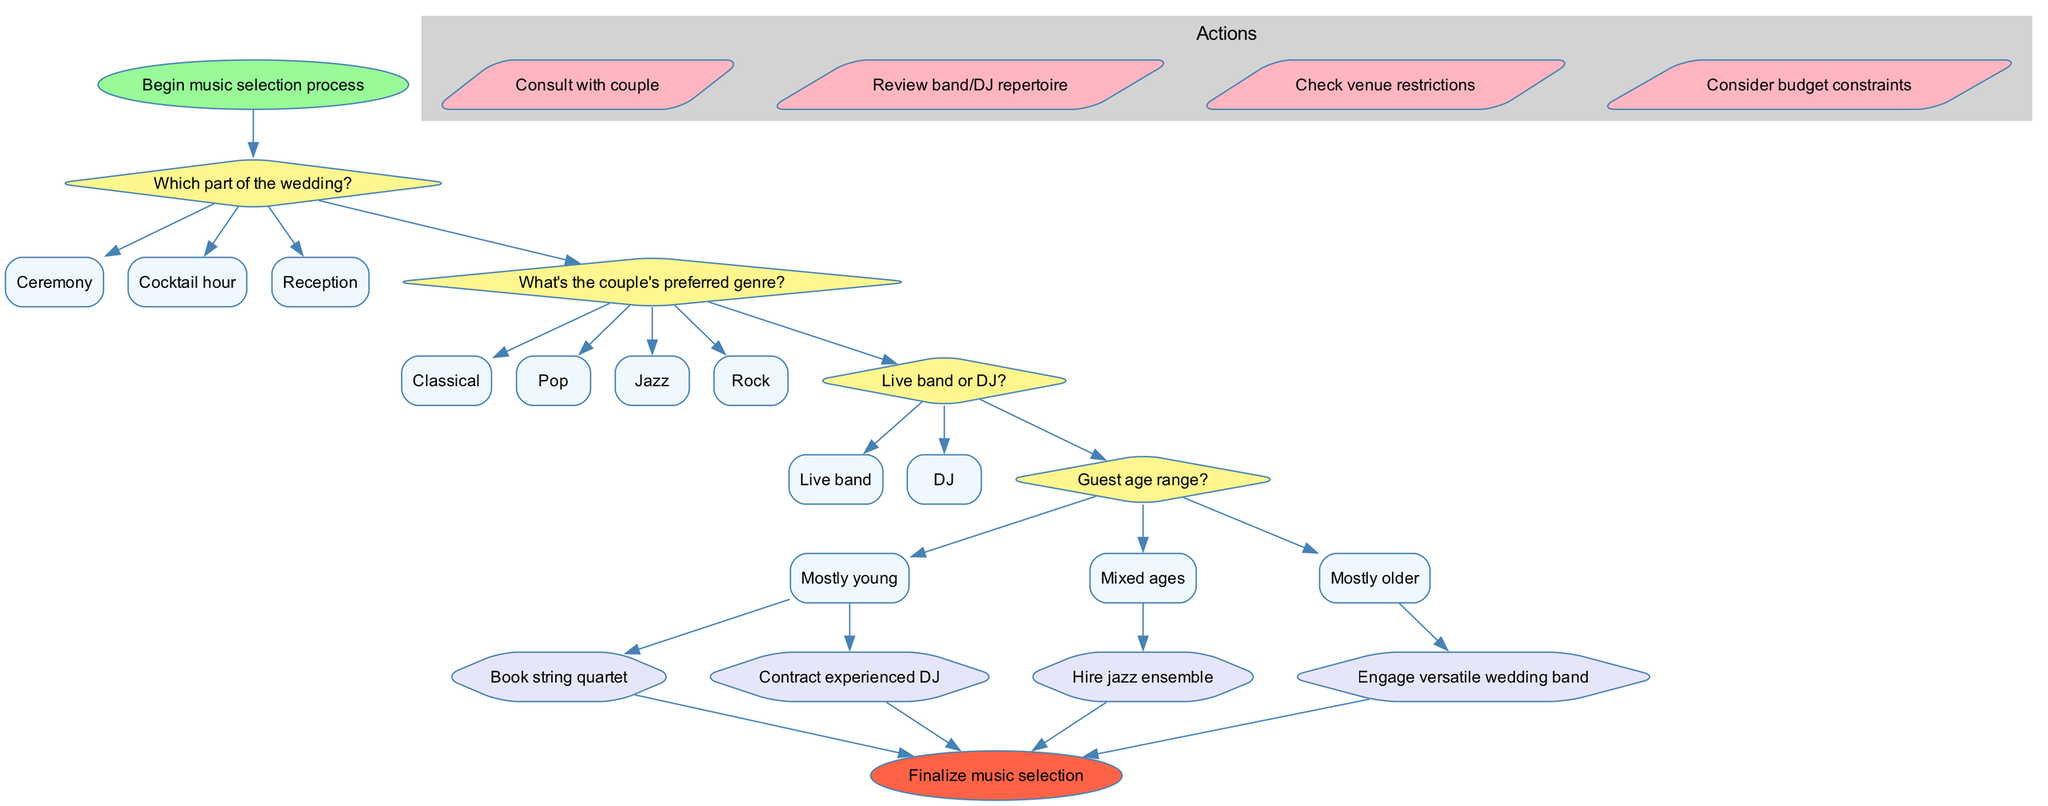What is the first step in the music selection process? The diagram indicates that the process starts with the node labeled "Begin music selection process."
Answer: Begin music selection process How many decision nodes are present in the diagram? The diagram includes four decision nodes, each identified by the questions posed regarding selecting appropriate music.
Answer: 4 What is one of the options for the question about the couple's preferred genre? The diagram lists four options for this decision, one of which is "Jazz."
Answer: Jazz What shape are the action nodes in the diagram? According to the diagram, action nodes are represented in the shape of a parallelogram.
Answer: Parallelogram Which option leads to hiring a jazz ensemble? The path leading to hiring a jazz ensemble follows the sequence from the decision on the part of the wedding, moving to the couple's preferred genre being "Jazz," and continuing from that option.
Answer: Jazz What is the outcome if the guest age range is "Mostly older"? The diagram indicates that if the guest age range is "Mostly older," the outcome will lead to engaging a versatile wedding band.
Answer: Engage versatile wedding band How do actions relate to decisions in the flowchart? Actions are shown as occurring after decisions, indicating that once a decision has been made (such as on genre or guest age range), relevant actions can be taken, such as reviewing band repertoire or considering budget constraints.
Answer: After decisions What does the final node represent in the flowchart? The end node, labeled "Finalize music selection," signifies the conclusion of the process where all selections and arrangements are consolidated.
Answer: Finalize music selection 